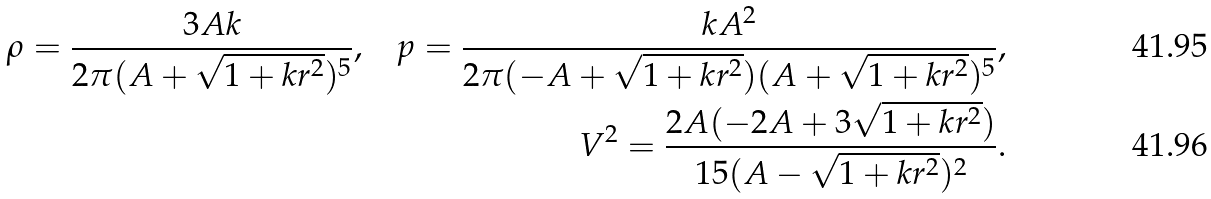Convert formula to latex. <formula><loc_0><loc_0><loc_500><loc_500>\rho = \frac { 3 A k } { 2 \pi ( A + \sqrt { 1 + k r ^ { 2 } } ) ^ { 5 } } \text {,} \quad p = \frac { k A ^ { 2 } } { 2 \pi ( - A + \sqrt { 1 + k r ^ { 2 } } ) ( A + \sqrt { 1 + k r ^ { 2 } } ) ^ { 5 } } \text {,} \\ V ^ { 2 } = \frac { 2 A ( - 2 A + 3 \sqrt { 1 + k r ^ { 2 } } ) } { 1 5 ( A - \sqrt { 1 + k r ^ { 2 } } ) ^ { 2 } } .</formula> 